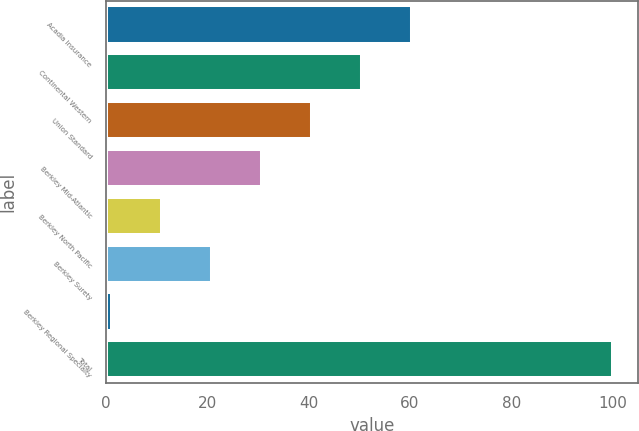Convert chart. <chart><loc_0><loc_0><loc_500><loc_500><bar_chart><fcel>Acadia Insurance<fcel>Continental Western<fcel>Union Standard<fcel>Berkley Mid-Atlantic<fcel>Berkley North Pacific<fcel>Berkley Surety<fcel>Berkley Regional Specialty<fcel>Total<nl><fcel>60.48<fcel>50.6<fcel>40.72<fcel>30.84<fcel>11.08<fcel>20.96<fcel>1.2<fcel>100<nl></chart> 